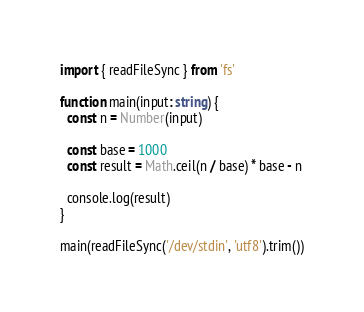<code> <loc_0><loc_0><loc_500><loc_500><_TypeScript_>import { readFileSync } from 'fs'

function main(input: string) {
  const n = Number(input)

  const base = 1000
  const result = Math.ceil(n / base) * base - n

  console.log(result)
}

main(readFileSync('/dev/stdin', 'utf8').trim())
</code> 